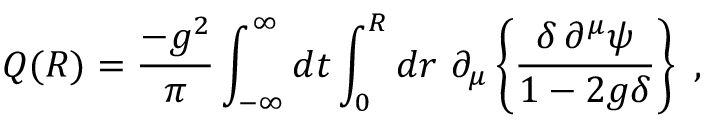Convert formula to latex. <formula><loc_0><loc_0><loc_500><loc_500>Q ( R ) = \frac { - g ^ { 2 } } { \pi } \int _ { - \infty } ^ { \infty } d t \int _ { 0 } ^ { R } d r \partial _ { \mu } \left \{ \frac { \delta \, \partial ^ { \mu } \psi } { 1 - 2 g \delta } \right ,</formula> 